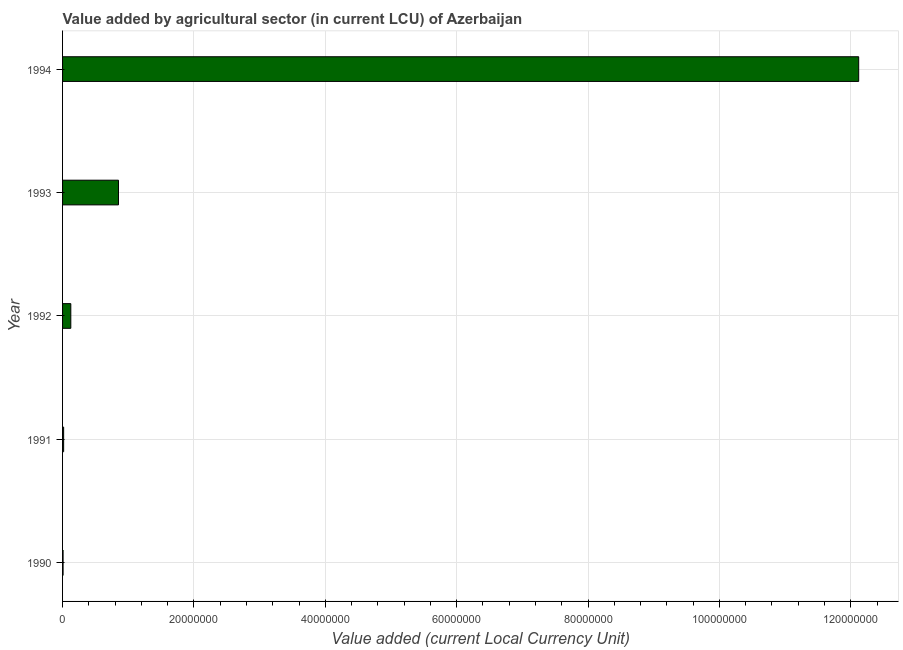Does the graph contain any zero values?
Ensure brevity in your answer.  No. What is the title of the graph?
Make the answer very short. Value added by agricultural sector (in current LCU) of Azerbaijan. What is the label or title of the X-axis?
Your answer should be very brief. Value added (current Local Currency Unit). What is the value added by agriculture sector in 1990?
Keep it short and to the point. 7.77e+04. Across all years, what is the maximum value added by agriculture sector?
Offer a terse response. 1.21e+08. Across all years, what is the minimum value added by agriculture sector?
Your answer should be compact. 7.77e+04. What is the sum of the value added by agriculture sector?
Make the answer very short. 1.31e+08. What is the difference between the value added by agriculture sector in 1993 and 1994?
Offer a terse response. -1.13e+08. What is the average value added by agriculture sector per year?
Your response must be concise. 2.62e+07. What is the median value added by agriculture sector?
Your answer should be compact. 1.26e+06. What is the ratio of the value added by agriculture sector in 1991 to that in 1993?
Make the answer very short. 0.02. What is the difference between the highest and the second highest value added by agriculture sector?
Offer a very short reply. 1.13e+08. Is the sum of the value added by agriculture sector in 1991 and 1993 greater than the maximum value added by agriculture sector across all years?
Keep it short and to the point. No. What is the difference between the highest and the lowest value added by agriculture sector?
Make the answer very short. 1.21e+08. How many bars are there?
Keep it short and to the point. 5. How many years are there in the graph?
Provide a succinct answer. 5. Are the values on the major ticks of X-axis written in scientific E-notation?
Ensure brevity in your answer.  No. What is the Value added (current Local Currency Unit) of 1990?
Your response must be concise. 7.77e+04. What is the Value added (current Local Currency Unit) of 1991?
Your response must be concise. 1.63e+05. What is the Value added (current Local Currency Unit) of 1992?
Provide a succinct answer. 1.26e+06. What is the Value added (current Local Currency Unit) of 1993?
Your answer should be compact. 8.51e+06. What is the Value added (current Local Currency Unit) of 1994?
Offer a very short reply. 1.21e+08. What is the difference between the Value added (current Local Currency Unit) in 1990 and 1991?
Provide a short and direct response. -8.52e+04. What is the difference between the Value added (current Local Currency Unit) in 1990 and 1992?
Give a very brief answer. -1.18e+06. What is the difference between the Value added (current Local Currency Unit) in 1990 and 1993?
Keep it short and to the point. -8.43e+06. What is the difference between the Value added (current Local Currency Unit) in 1990 and 1994?
Your answer should be very brief. -1.21e+08. What is the difference between the Value added (current Local Currency Unit) in 1991 and 1992?
Provide a succinct answer. -1.09e+06. What is the difference between the Value added (current Local Currency Unit) in 1991 and 1993?
Your response must be concise. -8.35e+06. What is the difference between the Value added (current Local Currency Unit) in 1991 and 1994?
Keep it short and to the point. -1.21e+08. What is the difference between the Value added (current Local Currency Unit) in 1992 and 1993?
Your answer should be very brief. -7.26e+06. What is the difference between the Value added (current Local Currency Unit) in 1992 and 1994?
Provide a succinct answer. -1.20e+08. What is the difference between the Value added (current Local Currency Unit) in 1993 and 1994?
Provide a short and direct response. -1.13e+08. What is the ratio of the Value added (current Local Currency Unit) in 1990 to that in 1991?
Offer a terse response. 0.48. What is the ratio of the Value added (current Local Currency Unit) in 1990 to that in 1992?
Provide a succinct answer. 0.06. What is the ratio of the Value added (current Local Currency Unit) in 1990 to that in 1993?
Ensure brevity in your answer.  0.01. What is the ratio of the Value added (current Local Currency Unit) in 1991 to that in 1992?
Your answer should be very brief. 0.13. What is the ratio of the Value added (current Local Currency Unit) in 1991 to that in 1993?
Offer a terse response. 0.02. What is the ratio of the Value added (current Local Currency Unit) in 1991 to that in 1994?
Offer a terse response. 0. What is the ratio of the Value added (current Local Currency Unit) in 1992 to that in 1993?
Your answer should be compact. 0.15. What is the ratio of the Value added (current Local Currency Unit) in 1993 to that in 1994?
Give a very brief answer. 0.07. 